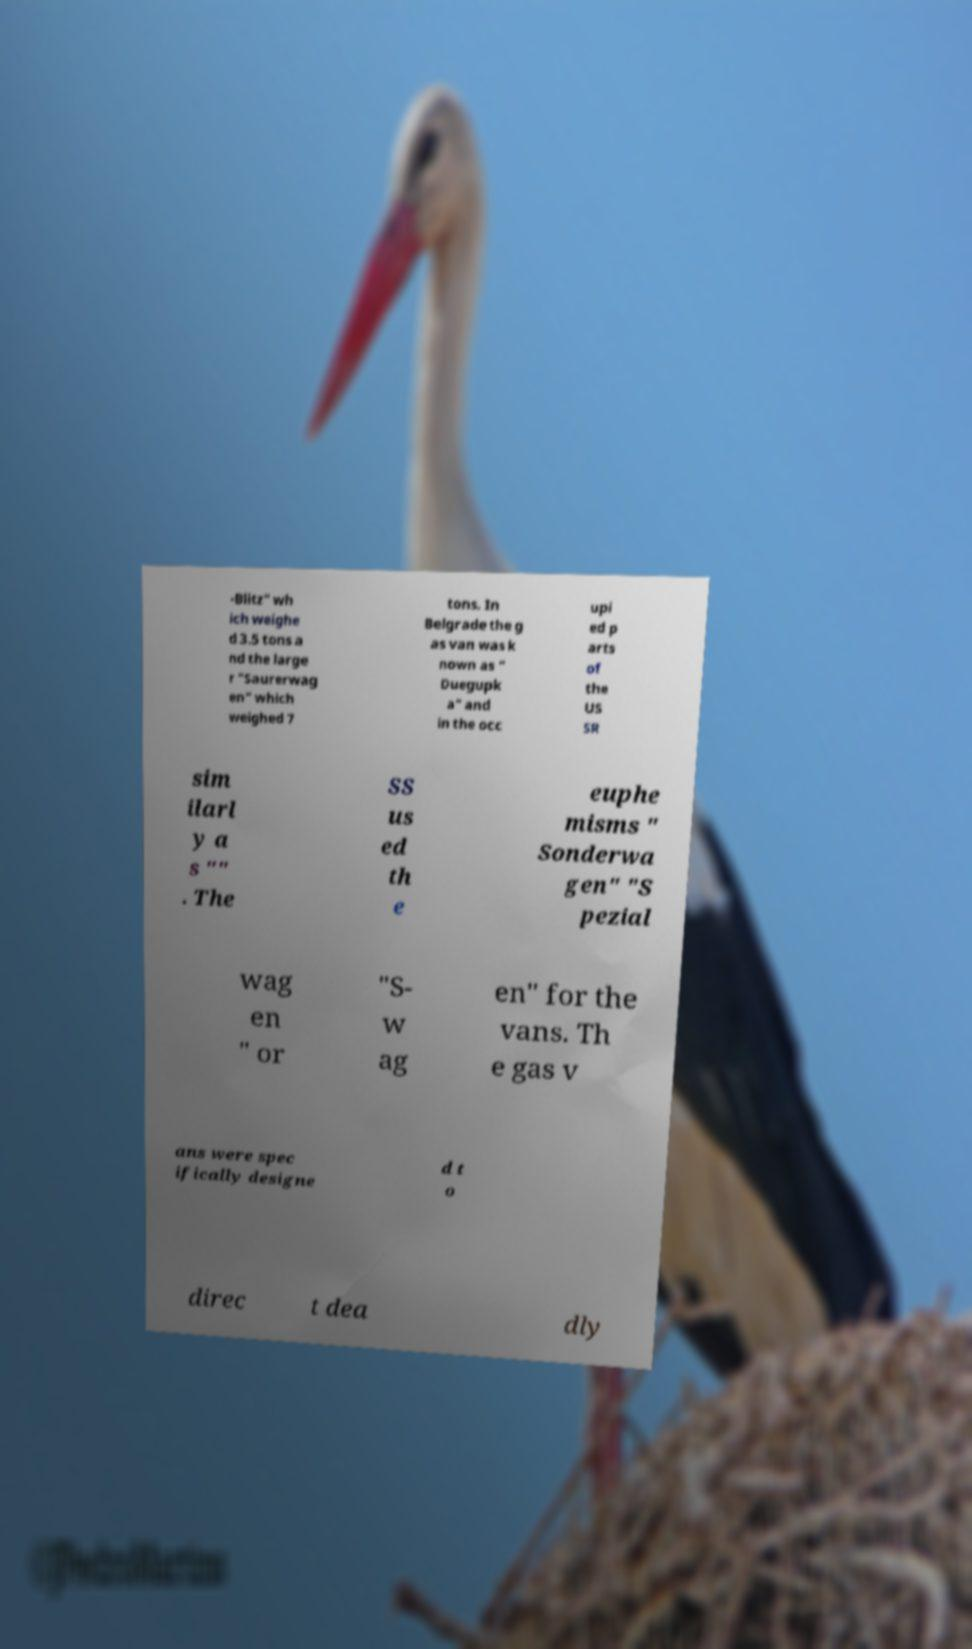There's text embedded in this image that I need extracted. Can you transcribe it verbatim? -Blitz" wh ich weighe d 3.5 tons a nd the large r "Saurerwag en" which weighed 7 tons. In Belgrade the g as van was k nown as " Duegupk a" and in the occ upi ed p arts of the US SR sim ilarl y a s "" . The SS us ed th e euphe misms " Sonderwa gen" "S pezial wag en " or "S- w ag en" for the vans. Th e gas v ans were spec ifically designe d t o direc t dea dly 